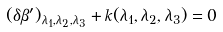<formula> <loc_0><loc_0><loc_500><loc_500>( \delta \beta ^ { \prime } ) _ { \lambda _ { 1 } , \lambda _ { 2 } , \lambda _ { 3 } } + k ( \lambda _ { 1 } , \lambda _ { 2 } , \lambda _ { 3 } ) = 0</formula> 